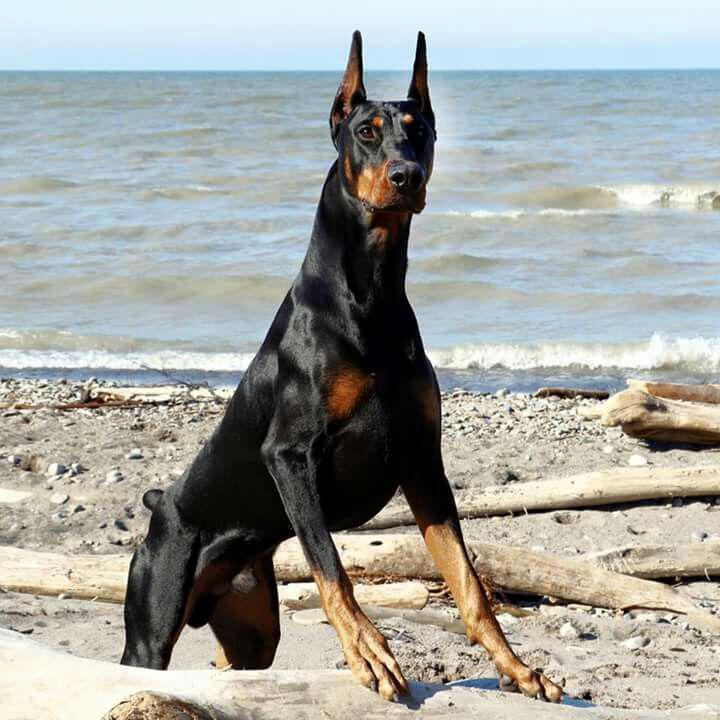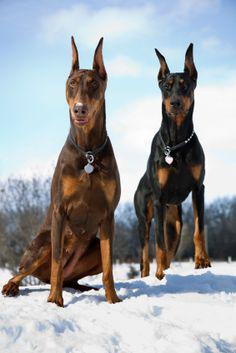The first image is the image on the left, the second image is the image on the right. Considering the images on both sides, is "Only one dog has a collar on" valid? Answer yes or no. No. The first image is the image on the left, the second image is the image on the right. For the images shown, is this caption "All dogs gaze leftward and are dobermans with erect ears, and one dog has its mouth open and tongue hanging past its lower lip." true? Answer yes or no. No. 